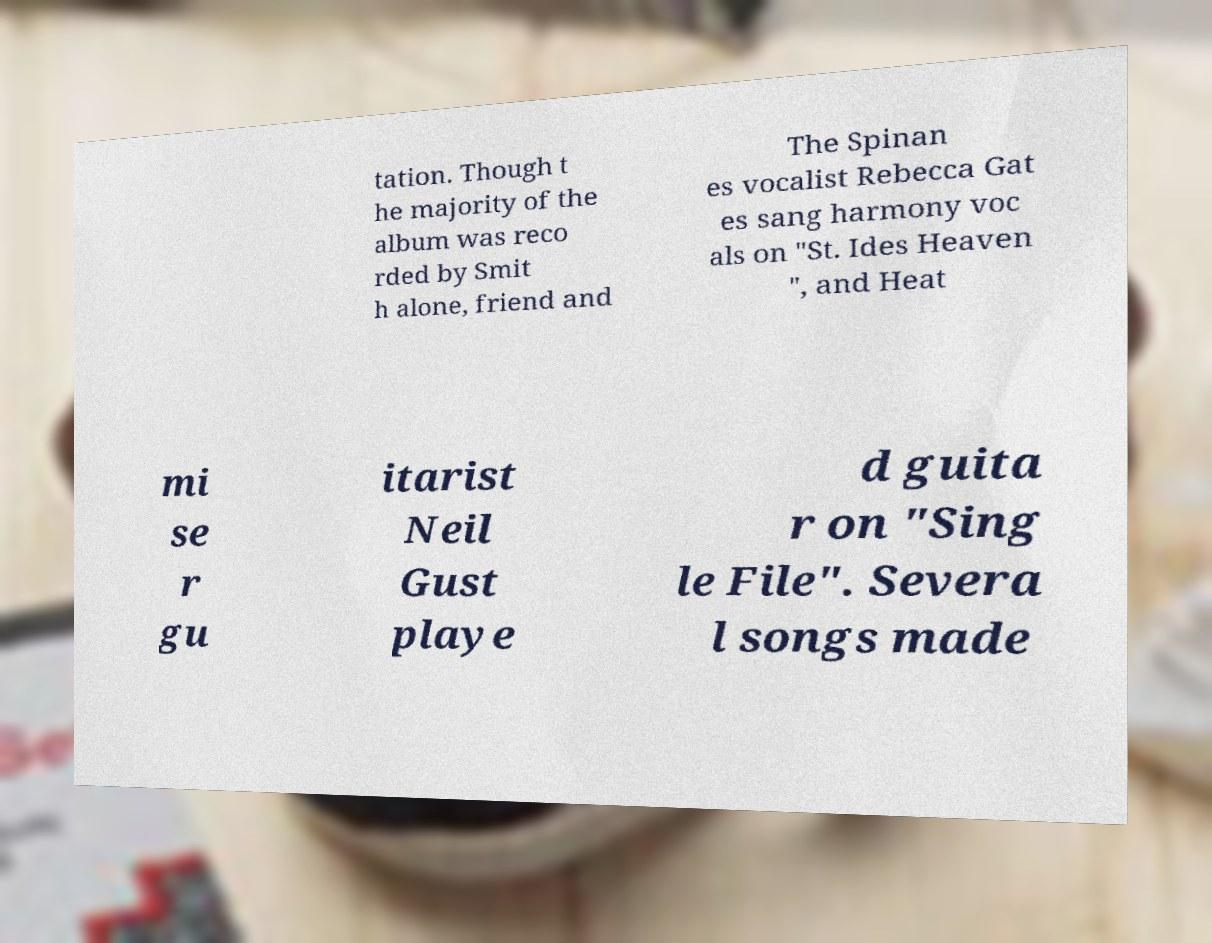Please identify and transcribe the text found in this image. tation. Though t he majority of the album was reco rded by Smit h alone, friend and The Spinan es vocalist Rebecca Gat es sang harmony voc als on "St. Ides Heaven ", and Heat mi se r gu itarist Neil Gust playe d guita r on "Sing le File". Severa l songs made 